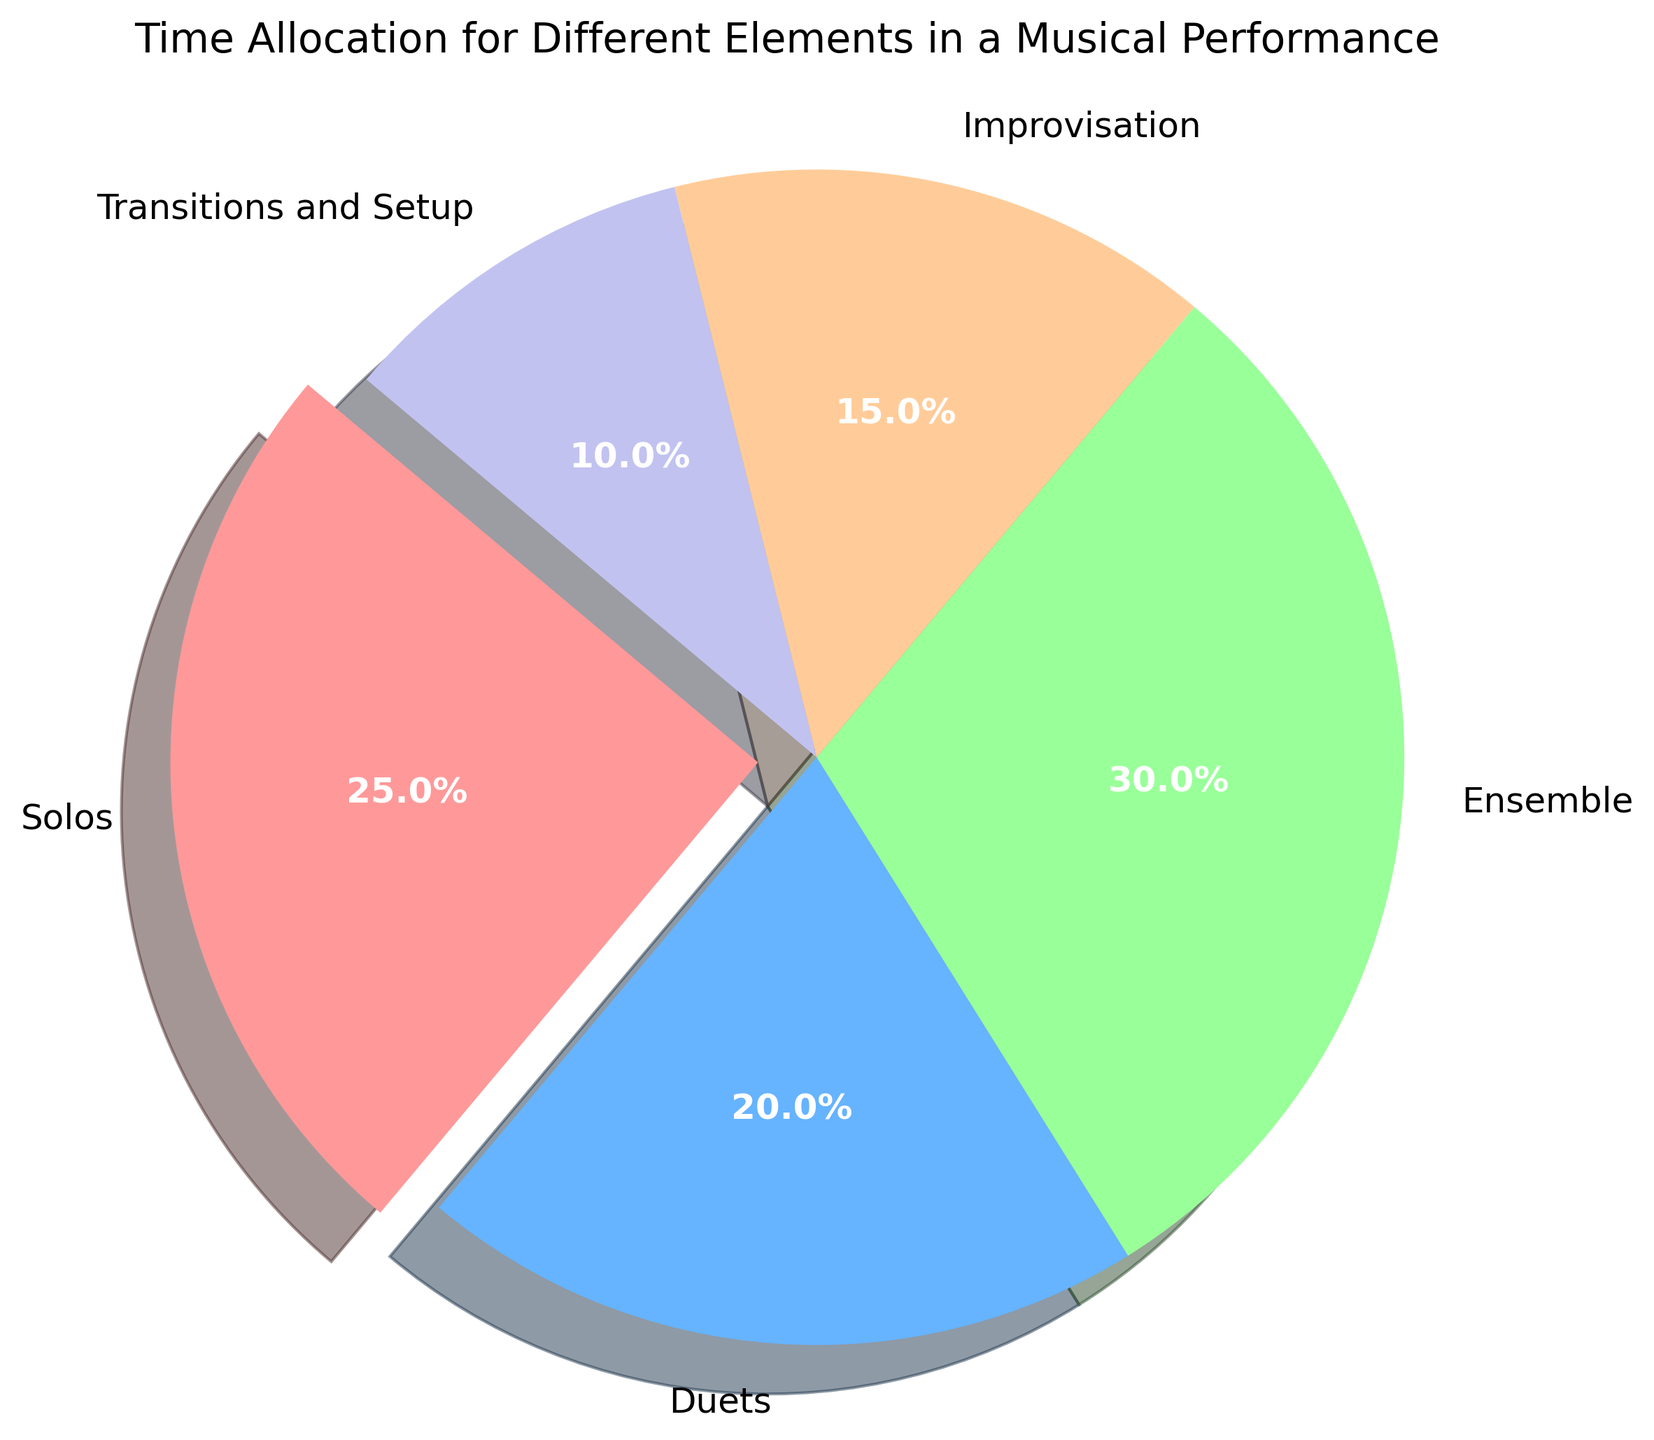What percentage of the performance is dedicated to Duets compared to Solos? Look at the pie chart to find the time allocation percentages for both Duets and Solos. Duets are allocated 20% of the time and Solos are allocated 25%. To compare, we see that Solos have a larger percentage.
Answer: Solos What is the combined time allocation for Solos, Duets, and Ensemble pieces? Look at the pie chart to find the individual percentages for Solos, Duets, and Ensemble. Solos are 25%, Duets are 20%, and Ensemble is 30%. Adding these together gives 25 + 20 + 30 = 75%.
Answer: 75% Does Improvisation take up more or less time than Transitions and Setup? Look at the pie chart to find the time allocations for Improvisation and Transitions and Setup. Improvisation is 15% and Transitions and Setup is 10%. 15% is more than 10%, so Improvisation takes up more time.
Answer: More Which element has the smallest time allocation, and what is it? Look at the pie chart and identify the smallest segment. The segment labeled 'Transitions and Setup' is the smallest, with a time allocation of 10%.
Answer: Transitions and Setup, 10% How much more time is allocated to Ensemble compared to Improvisation? Look at the pie chart to find the time allocations for Ensemble and Improvisation. Ensemble is 30% and Improvisation is 15%. Subtracting these gives 30 - 15 = 15%.
Answer: 15% What is the visual aspect that immediately distinguishes Solos from other segments in the pie chart? The pie chart uses a different technique to visually highlight Solos. The Solos segment is slightly exploded out from the chart, making it stand out.
Answer: It is slightly exploded What is the average time allocation for Solos, Duets, and Improvisation? First, find the percentages: Solos (25%), Duets (20%), and Improvisation (15%). Add these together (25 + 20 + 15 = 60) and divide by 3 to find the average. The average is 60 / 3 = 20%.
Answer: 20% Which segment has a purple color, and what percentage of the total time does it represent? Look at the pie chart and identify the purple-colored segment. The segment labeled 'Transitions and Setup' is purple and represents 10% of the total time.
Answer: Transitions and Setup, 10% What is the ratio of time allocated to Ensemble to that allocated to Improvisation? Look at the pie chart for the allocations: Ensemble (30%) and Improvisation (15%). Take the ratio 30:15, which simplifies to 2:1.
Answer: 2:1 